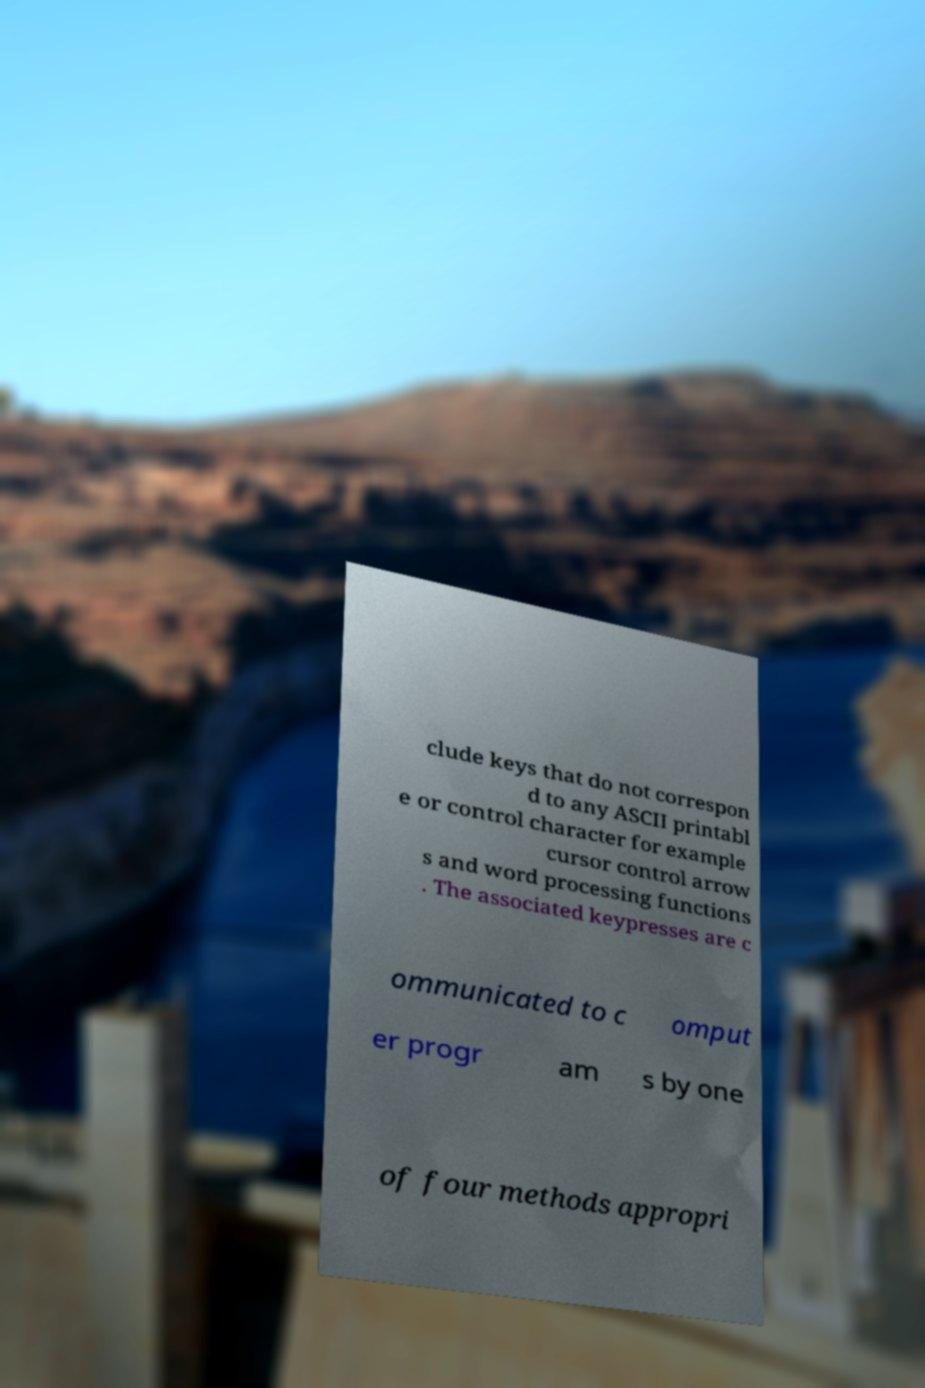Please identify and transcribe the text found in this image. clude keys that do not correspon d to any ASCII printabl e or control character for example cursor control arrow s and word processing functions . The associated keypresses are c ommunicated to c omput er progr am s by one of four methods appropri 